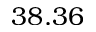<formula> <loc_0><loc_0><loc_500><loc_500>3 8 . 3 6</formula> 